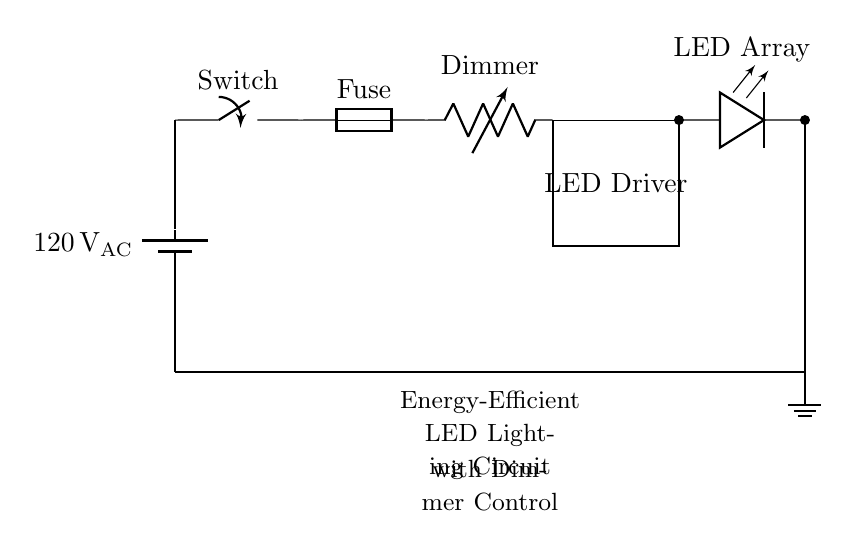What is the voltage of this circuit? The voltage is 120 volts AC, indicated next to the battery symbol at the top of the circuit.
Answer: 120 volts AC What is the role of the dimmer in this circuit? The dimmer is a variable resistor, which allows for adjustment of light intensity from the LED array by changing the resistance in the circuit.
Answer: Adjusting light intensity What connects the LED driver to the LED array? The LED driver connects to the LED array through direct wiring, indicated by the line with a connection point between them.
Answer: Direct wiring What component protects the circuit from overload? The fuse serves as a protection device that breaks the circuit in case of excessive current flowing through it.
Answer: Fuse How does the switch function in this circuit? The switch controls the flow of electricity, allowing or disallowing current from reaching the other components.
Answer: Controls current flow What type of lighting does this circuit provide? This circuit provides energy-efficient lighting, specifically using LED technology as indicated by the LED array component labeled in the circuit.
Answer: Energy-efficient LED lighting 